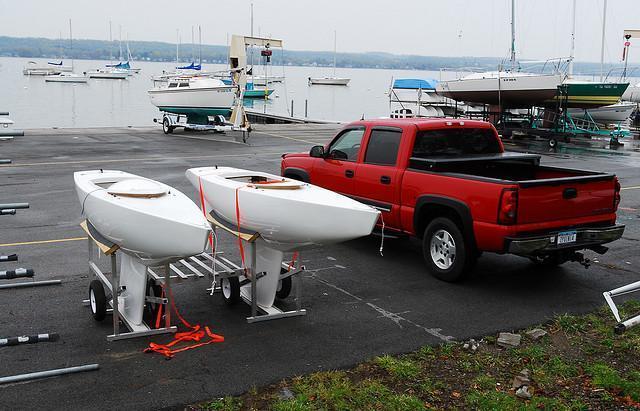How many boats are parked next to the red truck?
Give a very brief answer. 2. How many doors does the red truck have?
Give a very brief answer. 4. How many boats are visible?
Give a very brief answer. 5. 